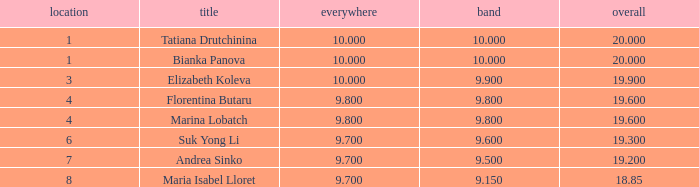What place had a ribbon below 9.8 and a 19.2 total? 7.0. 